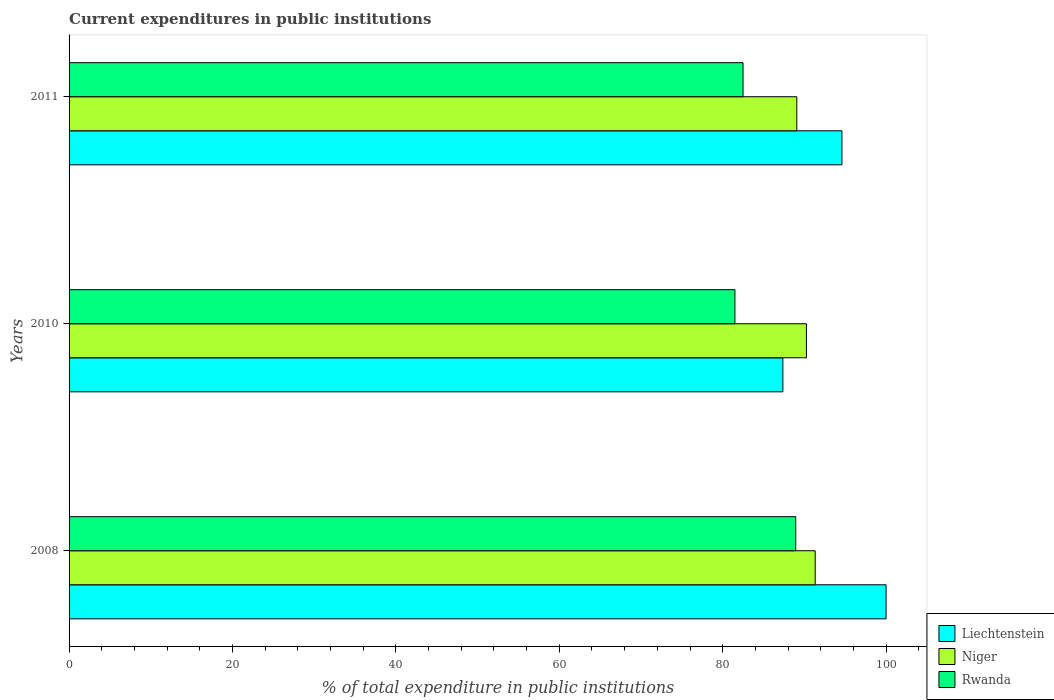How many different coloured bars are there?
Provide a succinct answer. 3. Are the number of bars per tick equal to the number of legend labels?
Keep it short and to the point. Yes. Are the number of bars on each tick of the Y-axis equal?
Keep it short and to the point. Yes. What is the label of the 1st group of bars from the top?
Your response must be concise. 2011. In how many cases, is the number of bars for a given year not equal to the number of legend labels?
Make the answer very short. 0. What is the current expenditures in public institutions in Niger in 2008?
Your answer should be compact. 91.32. Across all years, what is the maximum current expenditures in public institutions in Liechtenstein?
Your answer should be very brief. 100. Across all years, what is the minimum current expenditures in public institutions in Liechtenstein?
Ensure brevity in your answer.  87.37. In which year was the current expenditures in public institutions in Niger maximum?
Your answer should be compact. 2008. In which year was the current expenditures in public institutions in Rwanda minimum?
Offer a terse response. 2010. What is the total current expenditures in public institutions in Rwanda in the graph?
Your response must be concise. 252.93. What is the difference between the current expenditures in public institutions in Rwanda in 2008 and that in 2010?
Provide a succinct answer. 7.44. What is the difference between the current expenditures in public institutions in Rwanda in 2011 and the current expenditures in public institutions in Niger in 2008?
Provide a succinct answer. -8.83. What is the average current expenditures in public institutions in Liechtenstein per year?
Offer a very short reply. 93.99. In the year 2010, what is the difference between the current expenditures in public institutions in Liechtenstein and current expenditures in public institutions in Niger?
Keep it short and to the point. -2.88. What is the ratio of the current expenditures in public institutions in Niger in 2008 to that in 2010?
Offer a terse response. 1.01. Is the difference between the current expenditures in public institutions in Liechtenstein in 2010 and 2011 greater than the difference between the current expenditures in public institutions in Niger in 2010 and 2011?
Offer a very short reply. No. What is the difference between the highest and the second highest current expenditures in public institutions in Rwanda?
Your answer should be compact. 6.45. What is the difference between the highest and the lowest current expenditures in public institutions in Rwanda?
Provide a succinct answer. 7.44. What does the 1st bar from the top in 2011 represents?
Your answer should be compact. Rwanda. What does the 2nd bar from the bottom in 2008 represents?
Give a very brief answer. Niger. Is it the case that in every year, the sum of the current expenditures in public institutions in Niger and current expenditures in public institutions in Liechtenstein is greater than the current expenditures in public institutions in Rwanda?
Offer a very short reply. Yes. How many bars are there?
Provide a short and direct response. 9. How many years are there in the graph?
Give a very brief answer. 3. What is the difference between two consecutive major ticks on the X-axis?
Make the answer very short. 20. Are the values on the major ticks of X-axis written in scientific E-notation?
Ensure brevity in your answer.  No. Does the graph contain any zero values?
Provide a succinct answer. No. Does the graph contain grids?
Make the answer very short. No. How are the legend labels stacked?
Your answer should be compact. Vertical. What is the title of the graph?
Your response must be concise. Current expenditures in public institutions. Does "Faeroe Islands" appear as one of the legend labels in the graph?
Give a very brief answer. No. What is the label or title of the X-axis?
Give a very brief answer. % of total expenditure in public institutions. What is the % of total expenditure in public institutions in Niger in 2008?
Your answer should be compact. 91.32. What is the % of total expenditure in public institutions in Rwanda in 2008?
Your response must be concise. 88.94. What is the % of total expenditure in public institutions of Liechtenstein in 2010?
Your response must be concise. 87.37. What is the % of total expenditure in public institutions of Niger in 2010?
Your answer should be very brief. 90.25. What is the % of total expenditure in public institutions in Rwanda in 2010?
Ensure brevity in your answer.  81.5. What is the % of total expenditure in public institutions of Liechtenstein in 2011?
Provide a short and direct response. 94.6. What is the % of total expenditure in public institutions in Niger in 2011?
Provide a short and direct response. 89.07. What is the % of total expenditure in public institutions in Rwanda in 2011?
Offer a terse response. 82.49. Across all years, what is the maximum % of total expenditure in public institutions in Niger?
Your response must be concise. 91.32. Across all years, what is the maximum % of total expenditure in public institutions in Rwanda?
Offer a terse response. 88.94. Across all years, what is the minimum % of total expenditure in public institutions of Liechtenstein?
Offer a terse response. 87.37. Across all years, what is the minimum % of total expenditure in public institutions of Niger?
Provide a succinct answer. 89.07. Across all years, what is the minimum % of total expenditure in public institutions of Rwanda?
Give a very brief answer. 81.5. What is the total % of total expenditure in public institutions in Liechtenstein in the graph?
Offer a terse response. 281.97. What is the total % of total expenditure in public institutions of Niger in the graph?
Offer a very short reply. 270.65. What is the total % of total expenditure in public institutions in Rwanda in the graph?
Offer a very short reply. 252.93. What is the difference between the % of total expenditure in public institutions of Liechtenstein in 2008 and that in 2010?
Your response must be concise. 12.63. What is the difference between the % of total expenditure in public institutions of Niger in 2008 and that in 2010?
Your response must be concise. 1.07. What is the difference between the % of total expenditure in public institutions of Rwanda in 2008 and that in 2010?
Your answer should be compact. 7.44. What is the difference between the % of total expenditure in public institutions of Liechtenstein in 2008 and that in 2011?
Keep it short and to the point. 5.4. What is the difference between the % of total expenditure in public institutions of Niger in 2008 and that in 2011?
Give a very brief answer. 2.25. What is the difference between the % of total expenditure in public institutions of Rwanda in 2008 and that in 2011?
Keep it short and to the point. 6.45. What is the difference between the % of total expenditure in public institutions in Liechtenstein in 2010 and that in 2011?
Provide a short and direct response. -7.23. What is the difference between the % of total expenditure in public institutions of Niger in 2010 and that in 2011?
Make the answer very short. 1.18. What is the difference between the % of total expenditure in public institutions of Rwanda in 2010 and that in 2011?
Keep it short and to the point. -0.99. What is the difference between the % of total expenditure in public institutions in Liechtenstein in 2008 and the % of total expenditure in public institutions in Niger in 2010?
Your answer should be very brief. 9.75. What is the difference between the % of total expenditure in public institutions of Liechtenstein in 2008 and the % of total expenditure in public institutions of Rwanda in 2010?
Your answer should be very brief. 18.5. What is the difference between the % of total expenditure in public institutions in Niger in 2008 and the % of total expenditure in public institutions in Rwanda in 2010?
Offer a terse response. 9.82. What is the difference between the % of total expenditure in public institutions in Liechtenstein in 2008 and the % of total expenditure in public institutions in Niger in 2011?
Your response must be concise. 10.93. What is the difference between the % of total expenditure in public institutions of Liechtenstein in 2008 and the % of total expenditure in public institutions of Rwanda in 2011?
Make the answer very short. 17.51. What is the difference between the % of total expenditure in public institutions in Niger in 2008 and the % of total expenditure in public institutions in Rwanda in 2011?
Ensure brevity in your answer.  8.83. What is the difference between the % of total expenditure in public institutions in Liechtenstein in 2010 and the % of total expenditure in public institutions in Niger in 2011?
Provide a succinct answer. -1.71. What is the difference between the % of total expenditure in public institutions in Liechtenstein in 2010 and the % of total expenditure in public institutions in Rwanda in 2011?
Your answer should be compact. 4.87. What is the difference between the % of total expenditure in public institutions in Niger in 2010 and the % of total expenditure in public institutions in Rwanda in 2011?
Your answer should be very brief. 7.76. What is the average % of total expenditure in public institutions of Liechtenstein per year?
Make the answer very short. 93.99. What is the average % of total expenditure in public institutions in Niger per year?
Ensure brevity in your answer.  90.22. What is the average % of total expenditure in public institutions of Rwanda per year?
Keep it short and to the point. 84.31. In the year 2008, what is the difference between the % of total expenditure in public institutions in Liechtenstein and % of total expenditure in public institutions in Niger?
Offer a very short reply. 8.68. In the year 2008, what is the difference between the % of total expenditure in public institutions of Liechtenstein and % of total expenditure in public institutions of Rwanda?
Offer a terse response. 11.06. In the year 2008, what is the difference between the % of total expenditure in public institutions in Niger and % of total expenditure in public institutions in Rwanda?
Your answer should be compact. 2.38. In the year 2010, what is the difference between the % of total expenditure in public institutions of Liechtenstein and % of total expenditure in public institutions of Niger?
Provide a succinct answer. -2.88. In the year 2010, what is the difference between the % of total expenditure in public institutions of Liechtenstein and % of total expenditure in public institutions of Rwanda?
Your answer should be compact. 5.87. In the year 2010, what is the difference between the % of total expenditure in public institutions of Niger and % of total expenditure in public institutions of Rwanda?
Provide a succinct answer. 8.75. In the year 2011, what is the difference between the % of total expenditure in public institutions of Liechtenstein and % of total expenditure in public institutions of Niger?
Give a very brief answer. 5.52. In the year 2011, what is the difference between the % of total expenditure in public institutions in Liechtenstein and % of total expenditure in public institutions in Rwanda?
Offer a very short reply. 12.1. In the year 2011, what is the difference between the % of total expenditure in public institutions of Niger and % of total expenditure in public institutions of Rwanda?
Make the answer very short. 6.58. What is the ratio of the % of total expenditure in public institutions in Liechtenstein in 2008 to that in 2010?
Offer a very short reply. 1.14. What is the ratio of the % of total expenditure in public institutions in Niger in 2008 to that in 2010?
Keep it short and to the point. 1.01. What is the ratio of the % of total expenditure in public institutions of Rwanda in 2008 to that in 2010?
Offer a terse response. 1.09. What is the ratio of the % of total expenditure in public institutions of Liechtenstein in 2008 to that in 2011?
Provide a short and direct response. 1.06. What is the ratio of the % of total expenditure in public institutions in Niger in 2008 to that in 2011?
Keep it short and to the point. 1.03. What is the ratio of the % of total expenditure in public institutions in Rwanda in 2008 to that in 2011?
Ensure brevity in your answer.  1.08. What is the ratio of the % of total expenditure in public institutions in Liechtenstein in 2010 to that in 2011?
Ensure brevity in your answer.  0.92. What is the ratio of the % of total expenditure in public institutions of Niger in 2010 to that in 2011?
Make the answer very short. 1.01. What is the ratio of the % of total expenditure in public institutions in Rwanda in 2010 to that in 2011?
Offer a terse response. 0.99. What is the difference between the highest and the second highest % of total expenditure in public institutions of Liechtenstein?
Give a very brief answer. 5.4. What is the difference between the highest and the second highest % of total expenditure in public institutions of Niger?
Offer a terse response. 1.07. What is the difference between the highest and the second highest % of total expenditure in public institutions in Rwanda?
Your answer should be very brief. 6.45. What is the difference between the highest and the lowest % of total expenditure in public institutions of Liechtenstein?
Provide a short and direct response. 12.63. What is the difference between the highest and the lowest % of total expenditure in public institutions in Niger?
Offer a very short reply. 2.25. What is the difference between the highest and the lowest % of total expenditure in public institutions in Rwanda?
Offer a terse response. 7.44. 